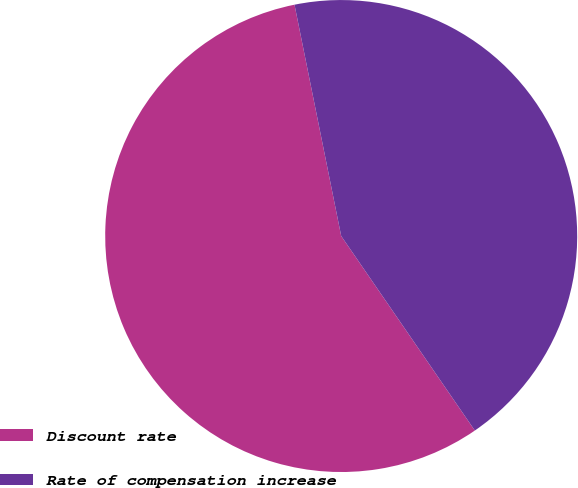<chart> <loc_0><loc_0><loc_500><loc_500><pie_chart><fcel>Discount rate<fcel>Rate of compensation increase<nl><fcel>56.41%<fcel>43.59%<nl></chart> 